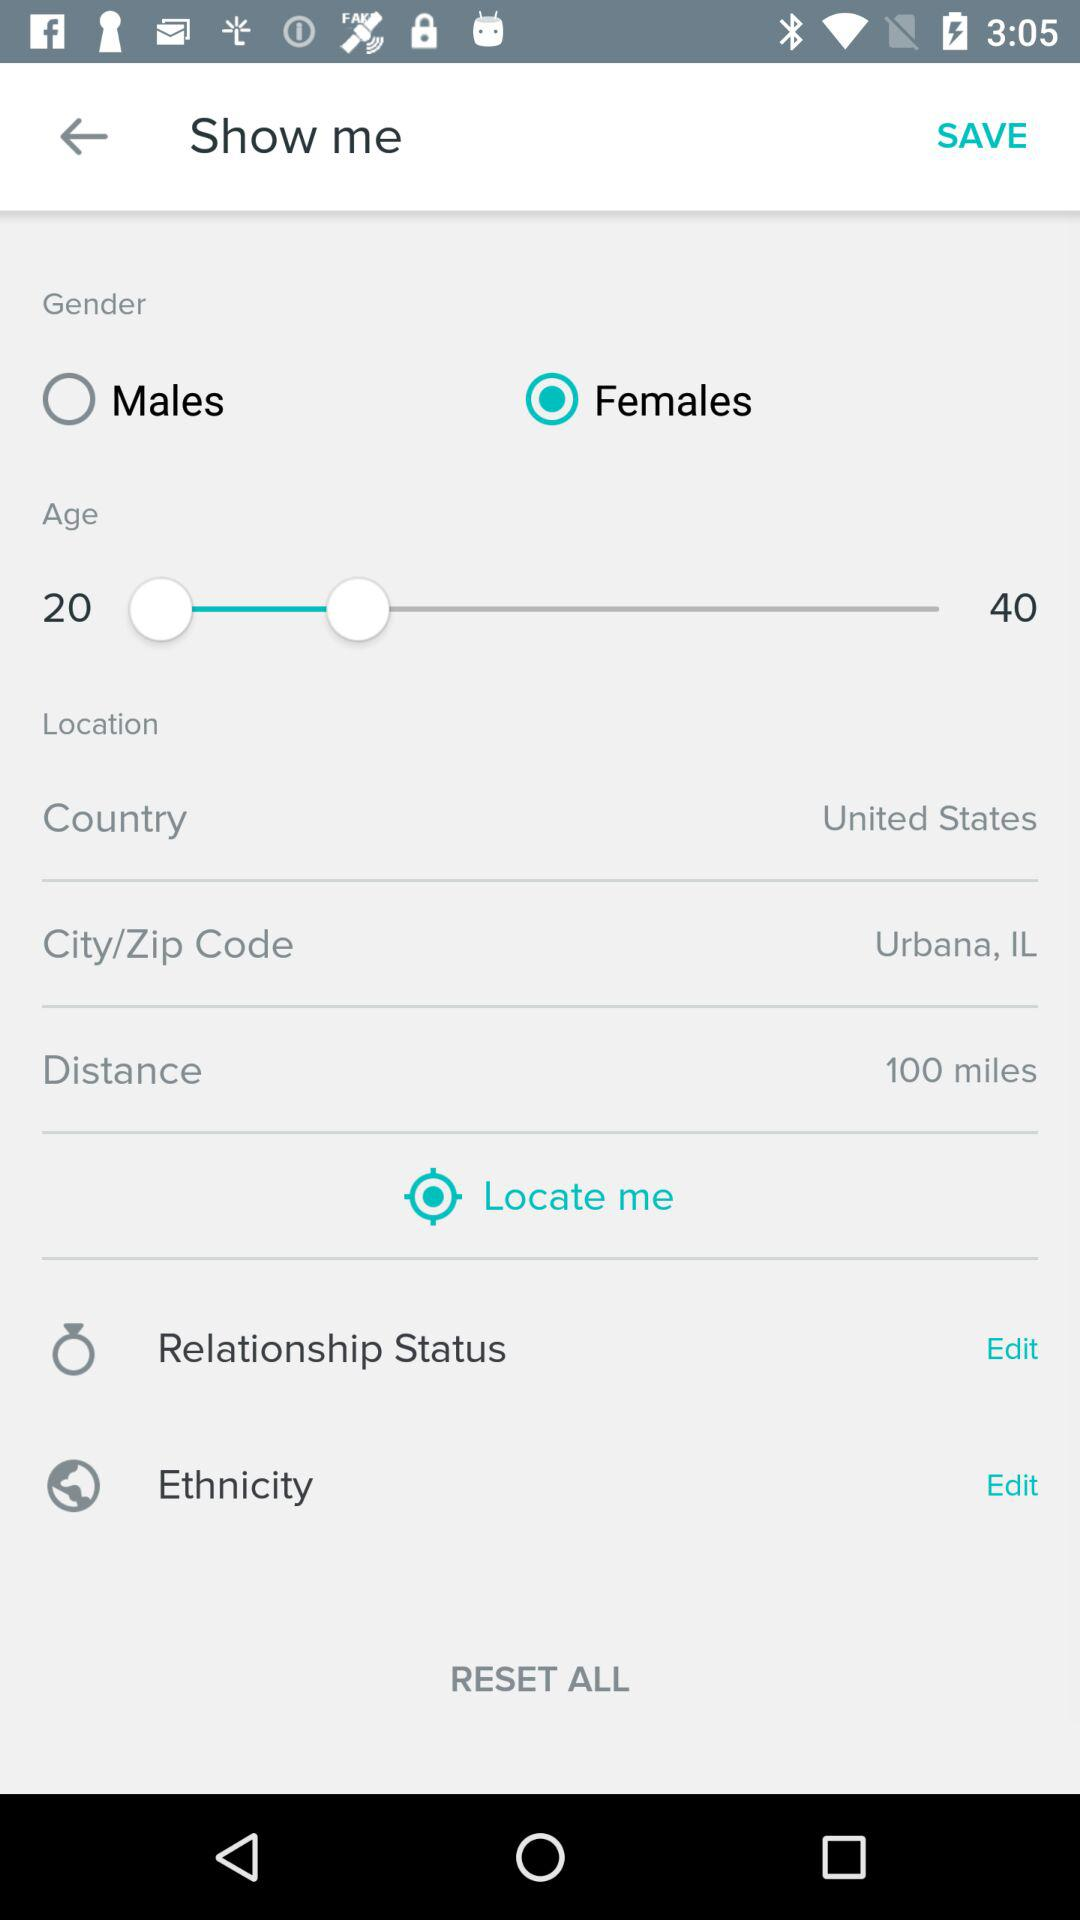What's the distance? The distance is 100 miles. 